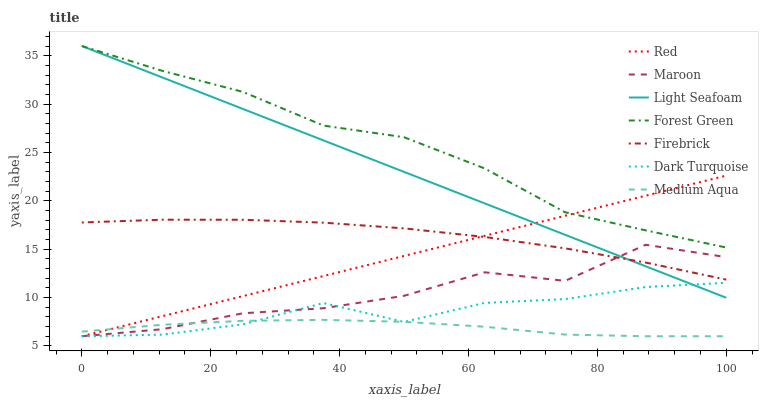Does Medium Aqua have the minimum area under the curve?
Answer yes or no. Yes. Does Forest Green have the maximum area under the curve?
Answer yes or no. Yes. Does Firebrick have the minimum area under the curve?
Answer yes or no. No. Does Firebrick have the maximum area under the curve?
Answer yes or no. No. Is Light Seafoam the smoothest?
Answer yes or no. Yes. Is Maroon the roughest?
Answer yes or no. Yes. Is Firebrick the smoothest?
Answer yes or no. No. Is Firebrick the roughest?
Answer yes or no. No. Does Dark Turquoise have the lowest value?
Answer yes or no. Yes. Does Firebrick have the lowest value?
Answer yes or no. No. Does Light Seafoam have the highest value?
Answer yes or no. Yes. Does Firebrick have the highest value?
Answer yes or no. No. Is Dark Turquoise less than Forest Green?
Answer yes or no. Yes. Is Firebrick greater than Dark Turquoise?
Answer yes or no. Yes. Does Light Seafoam intersect Forest Green?
Answer yes or no. Yes. Is Light Seafoam less than Forest Green?
Answer yes or no. No. Is Light Seafoam greater than Forest Green?
Answer yes or no. No. Does Dark Turquoise intersect Forest Green?
Answer yes or no. No. 